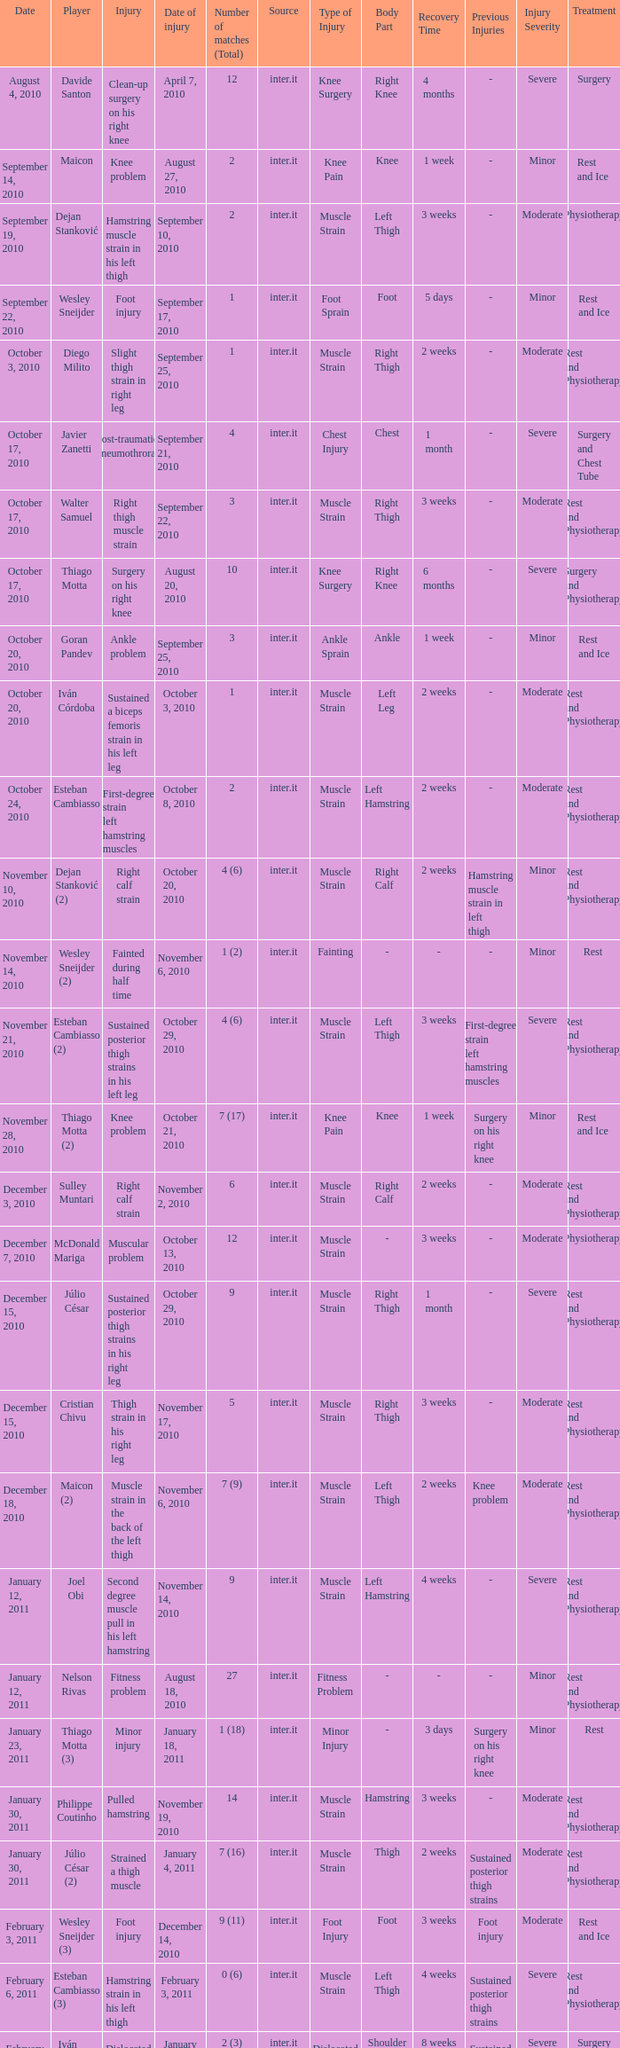How many times was the date october 3, 2010? 1.0. 